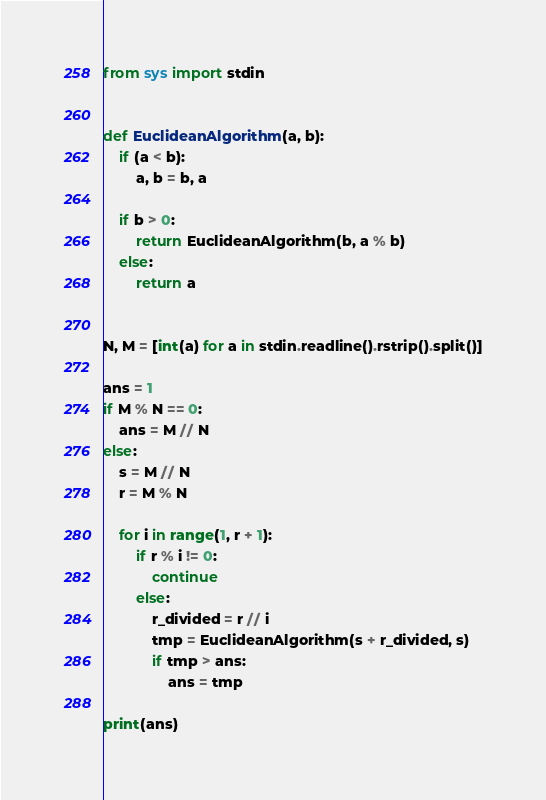Convert code to text. <code><loc_0><loc_0><loc_500><loc_500><_Python_>from sys import stdin


def EuclideanAlgorithm(a, b):
    if (a < b):
        a, b = b, a

    if b > 0:
        return EuclideanAlgorithm(b, a % b)
    else:
        return a


N, M = [int(a) for a in stdin.readline().rstrip().split()]

ans = 1
if M % N == 0:
    ans = M // N
else:
    s = M // N
    r = M % N

    for i in range(1, r + 1):
        if r % i != 0:
            continue
        else:
            r_divided = r // i
            tmp = EuclideanAlgorithm(s + r_divided, s)
            if tmp > ans:
                ans = tmp

print(ans)
</code> 